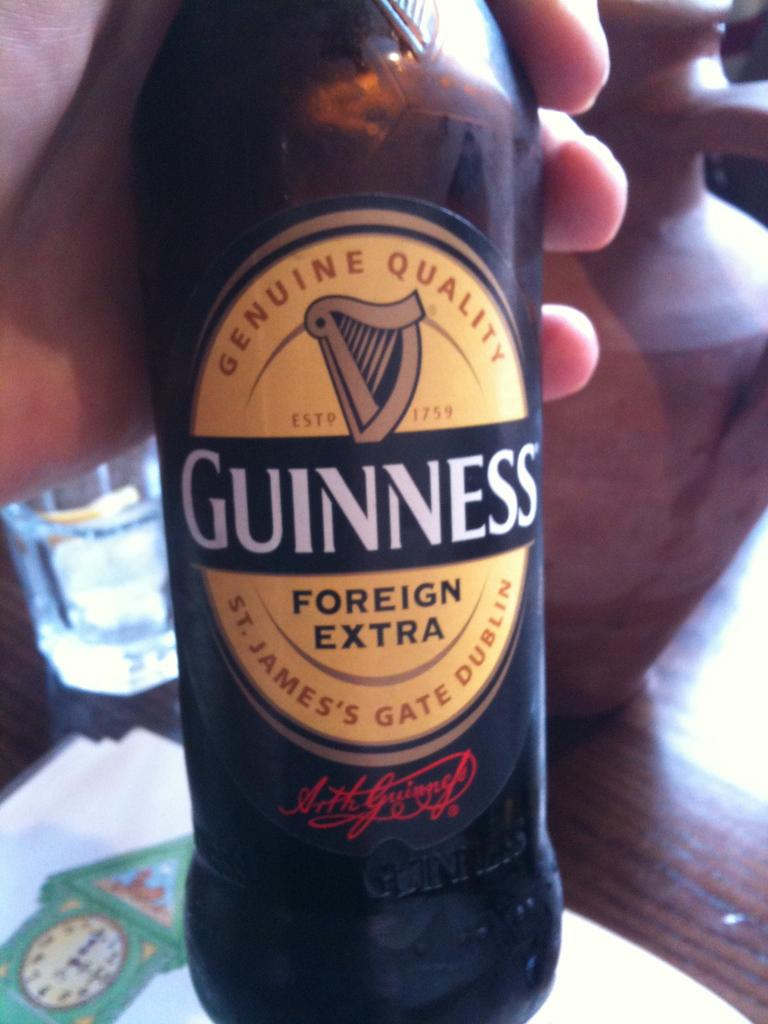What is the name of the wine bottle in the image? The wine bottle is named "Foreign Extra" in the image. Who is holding the wine bottle in the image? The wine bottle is held by a human hand in the image. What is present on the table in the image? There is a table in the image with a glass, a paper, and a pot on it. What type of tooth is visible in the image? There is no tooth visible in the image. What selection of items can be seen on the table in the image? The items on the table include a glass, a paper, and a pot, but there is no mention of a selection of items. 